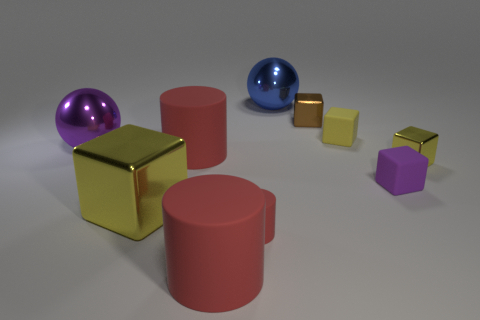What is the shape of the purple thing right of the tiny cylinder? The shape of the purple object located to the right of the small, golden cylinder is a cube. 